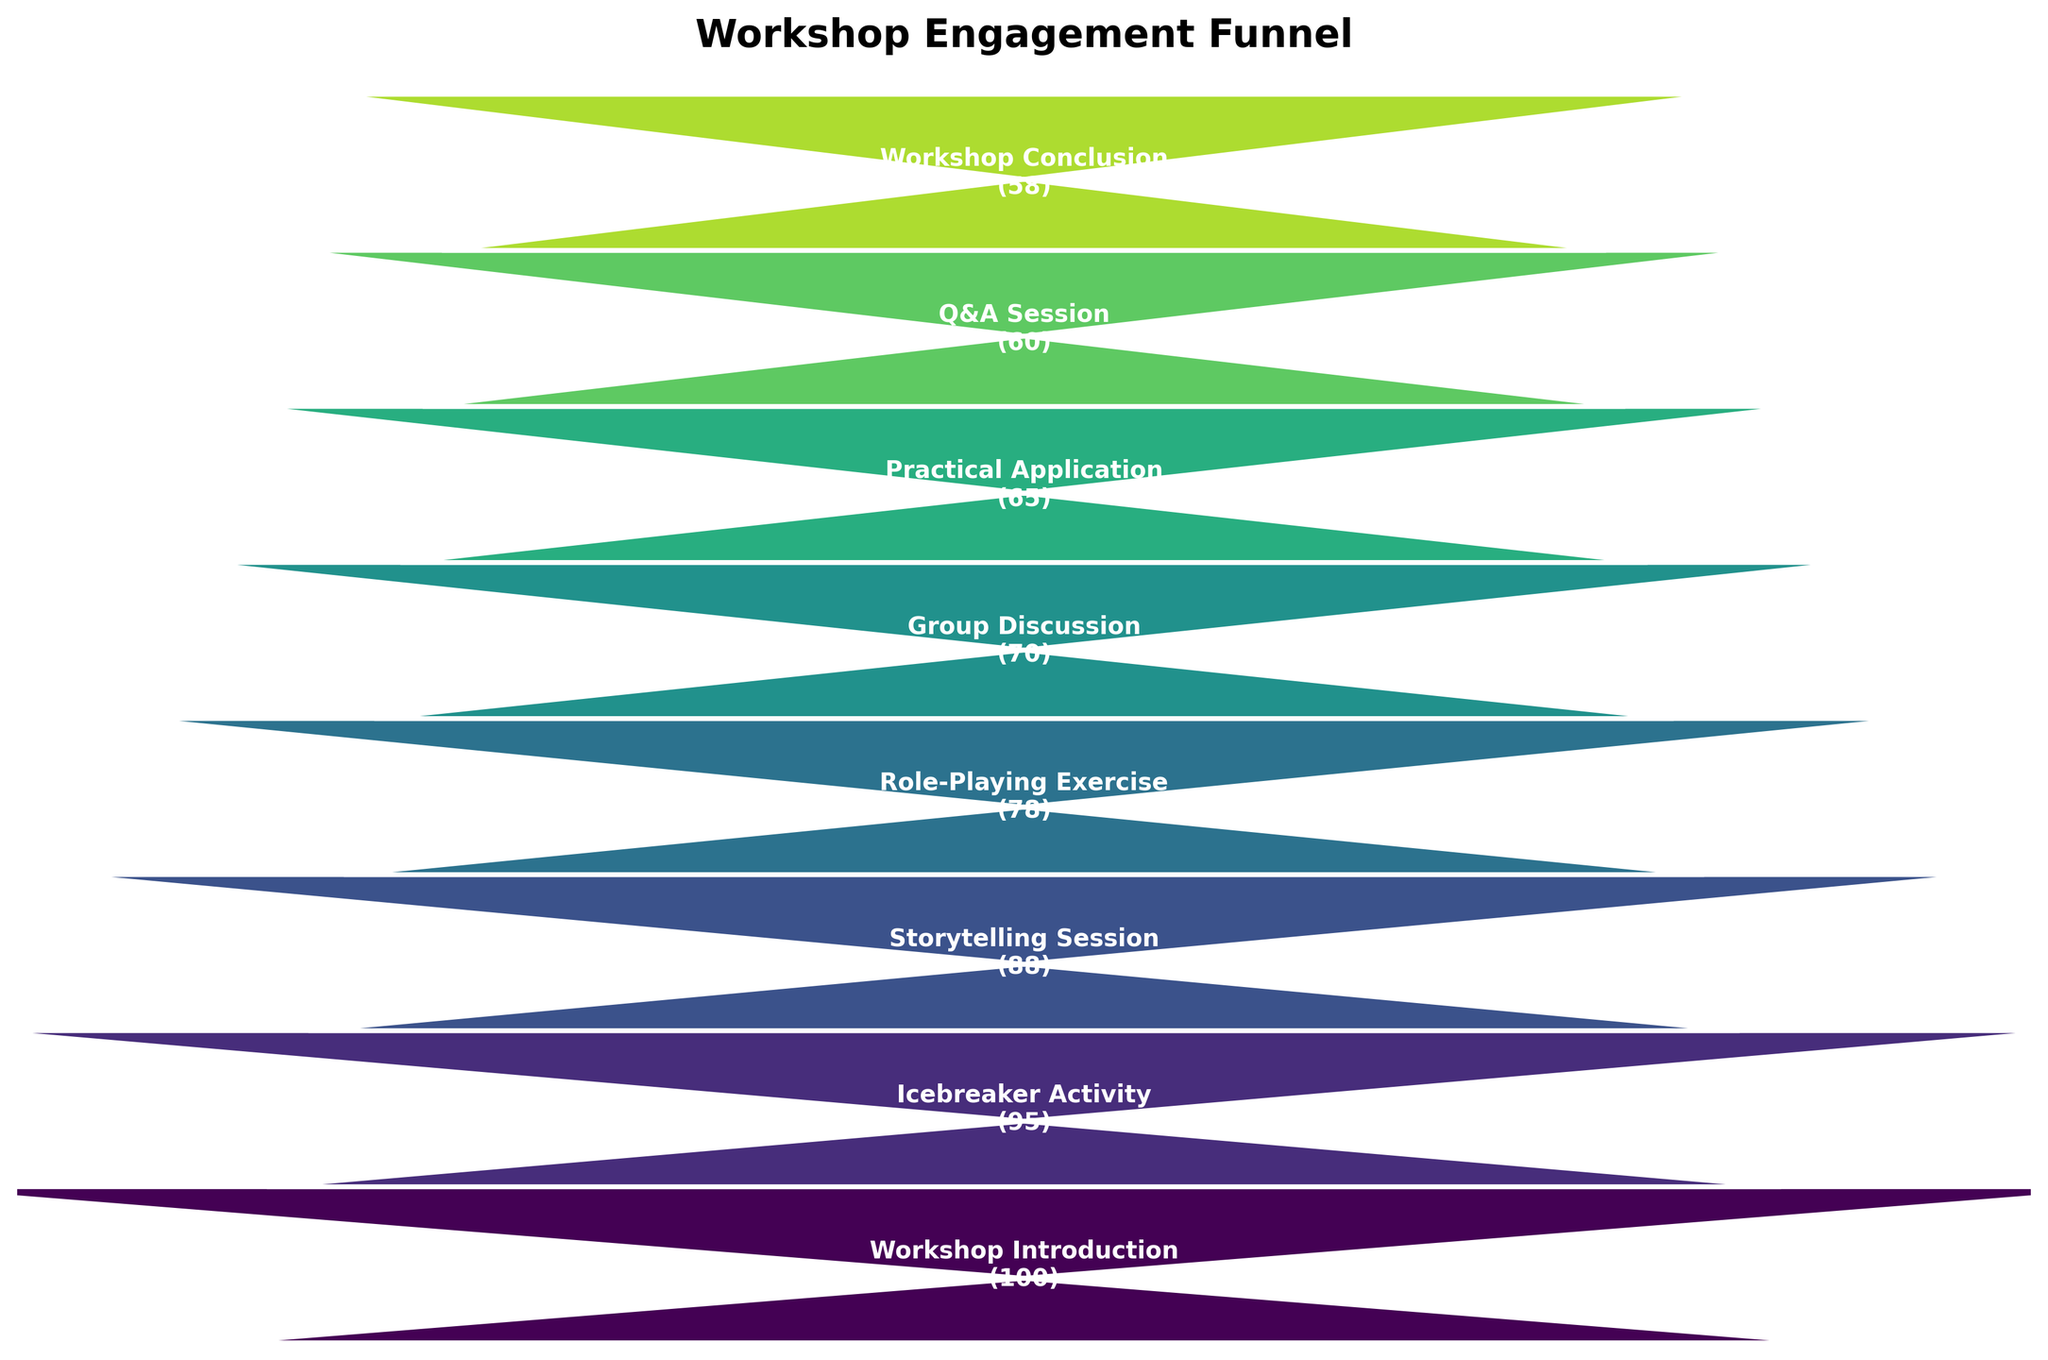What is the title of the chart? The title of the chart is prominently displayed at the top.
Answer: Workshop Engagement Funnel How many stages are represented in the funnel chart? You can count the number of distinct stages or steps listed vertically in the funnel chart.
Answer: 8 Which stage has the highest number of participants? By looking at the first stage at the top of the funnel, you can see the count of participants is the highest.
Answer: Workshop Introduction (100) What is the number of participants at the Workshop Conclusion stage? You can read the number of participants next to the label "Workshop Conclusion" at the bottom of the funnel.
Answer: 58 What is the difference in participants between the Icebreaker Activity and the Practical Application stage? Subtract the number of participants in the Practical Application stage from the number in the Icebreaker Activity stage: 95 - 65.
Answer: 30 Which stage experienced the largest drop in participants compared to its preceding stage? Calculate the differences in participants between each successive stage and identify the largest drop: 
(1) Workshop Introduction to Icebreaker Activity: 100 - 95 = 5 
(2) Icebreaker Activity to Storytelling Session: 95 - 88 = 7
(3) Storytelling Session to Role-Playing Exercise: 88 - 78 = 10
(4) Role-Playing Exercise to Group Discussion: 78 - 70 = 8
(5) Group Discussion to Practical Application: 70 - 65 = 5
(6) Practical Application to Q&A Session: 65 - 60 = 5
(7) Q&A Session to Workshop Conclusion: 60 - 58 = 2
The largest drop is between Storytelling Session and Role-Playing Exercise.
Answer: Storytelling Session to Role-Playing Exercise (10) What percentage of participants remained from the Workshop Introduction to the Workshop Conclusion? Calculate the percentage by dividing the number of participants in the Workshop Conclusion stage by the number in the Workshop Introduction stage and multiply by 100: (58 / 100) * 100.
Answer: 58% By how much did the participation decrease from the Storytelling Session to the Role-Playing Exercise? Subtract the number of participants in the Role-Playing Exercise stage from those in the Storytelling Session: 88 - 78.
Answer: 10 How many participants were there in total from the Storytelling Session to the Q&A Session? Add the number of participants in each stage from the Storytelling Session to the Q&A Session: 88 (Storytelling Session) + 78 (Role-Playing Exercise) + 70 (Group Discussion) + 65 (Practical Application) + 60 (Q&A Session).
Answer: 361 